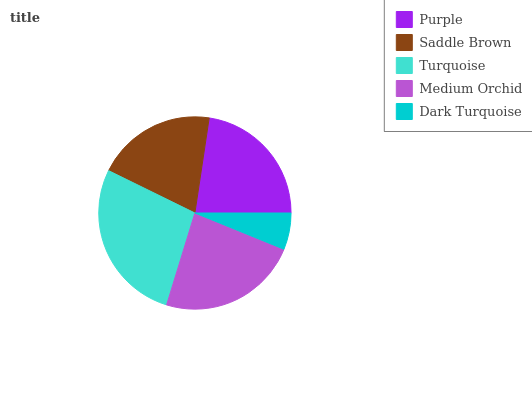Is Dark Turquoise the minimum?
Answer yes or no. Yes. Is Turquoise the maximum?
Answer yes or no. Yes. Is Saddle Brown the minimum?
Answer yes or no. No. Is Saddle Brown the maximum?
Answer yes or no. No. Is Purple greater than Saddle Brown?
Answer yes or no. Yes. Is Saddle Brown less than Purple?
Answer yes or no. Yes. Is Saddle Brown greater than Purple?
Answer yes or no. No. Is Purple less than Saddle Brown?
Answer yes or no. No. Is Purple the high median?
Answer yes or no. Yes. Is Purple the low median?
Answer yes or no. Yes. Is Turquoise the high median?
Answer yes or no. No. Is Medium Orchid the low median?
Answer yes or no. No. 